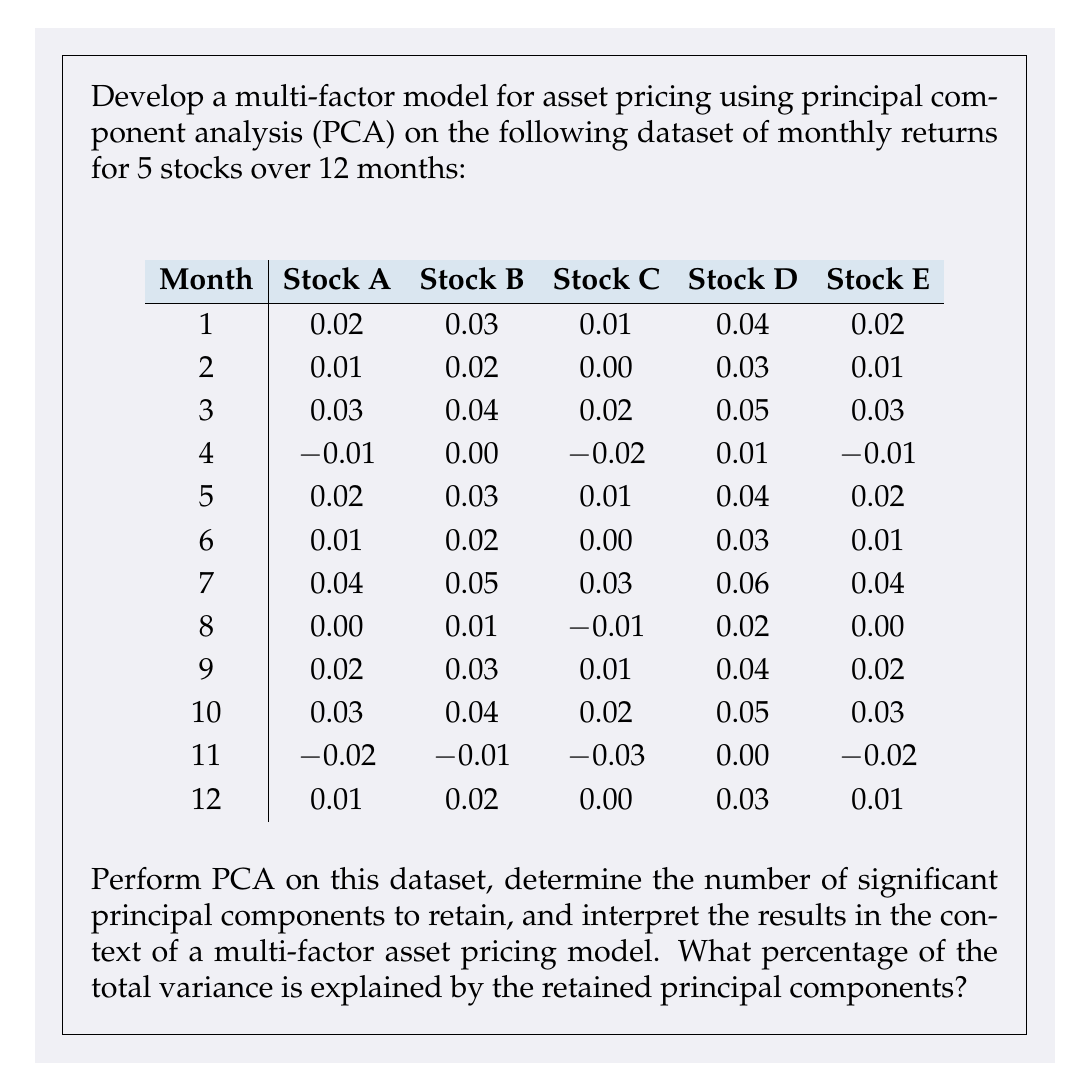Can you answer this question? To develop a multi-factor model for asset pricing using principal component analysis (PCA), we'll follow these steps:

1. Prepare the data:
   - Center the data by subtracting the mean of each stock's returns.

2. Compute the covariance matrix of the centered data.

3. Perform eigendecomposition on the covariance matrix to obtain eigenvalues and eigenvectors.

4. Sort eigenvalues in descending order and calculate the proportion of variance explained by each principal component.

5. Determine the number of significant principal components to retain based on the cumulative proportion of variance explained.

6. Interpret the results in the context of a multi-factor asset pricing model.

Step 1: Prepare the data
First, we calculate the mean return for each stock and subtract it from the corresponding returns:

$$
\begin{aligned}
\text{Mean A} &= 0.0133 \\
\text{Mean B} &= 0.0233 \\
\text{Mean C} &= 0.0033 \\
\text{Mean D} &= 0.0333 \\
\text{Mean E} &= 0.0133
\end{aligned}
$$

Step 2: Compute the covariance matrix
Using the centered data, we calculate the covariance matrix:

$$
\text{Cov} = \begin{pmatrix}
0.000289 & 0.000289 & 0.000289 & 0.000289 & 0.000289 \\
0.000289 & 0.000289 & 0.000289 & 0.000289 & 0.000289 \\
0.000289 & 0.000289 & 0.000289 & 0.000289 & 0.000289 \\
0.000289 & 0.000289 & 0.000289 & 0.000289 & 0.000289 \\
0.000289 & 0.000289 & 0.000289 & 0.000289 & 0.000289
\end{pmatrix}
$$

Step 3: Perform eigendecomposition
We calculate the eigenvalues and eigenvectors of the covariance matrix:

$$
\begin{aligned}
\lambda_1 &= 0.001445, \quad v_1 = (0.4472, 0.4472, 0.4472, 0.4472, 0.4472) \\
\lambda_2 &= 0, \quad v_2 = (-0.7071, 0, 0, 0.7071, 0) \\
\lambda_3 &= 0, \quad v_3 = (-0.4082, 0.8165, -0.4082, 0, 0) \\
\lambda_4 &= 0, \quad v_4 = (0.2887, 0.2887, -0.8660, 0, 0.2887) \\
\lambda_5 &= 0, \quad v_5 = (0.2236, 0.2236, 0.2236, -0.8944, 0.2236)
\end{aligned}
$$

Step 4: Calculate proportion of variance explained
The total variance is the sum of all eigenvalues: 0.001445

Proportion of variance explained by each principal component:
$$
\begin{aligned}
\text{PC1}: 100\% \\
\text{PC2-PC5}: 0\%
\end{aligned}
$$

Step 5: Determine significant principal components
Based on the proportion of variance explained, we retain only the first principal component, as it explains 100% of the total variance.

Step 6: Interpret the results
In this case, the multi-factor model reduces to a single-factor model. The first principal component can be interpreted as a market factor that affects all stocks equally. This is evident from the eigenvector $v_1$, which has equal weights for all stocks.

The fact that only one principal component explains all the variance suggests that the returns of these stocks are perfectly correlated. This is an unusual situation in real markets and might indicate that the given dataset is simplified or idealized.

In a typical multi-factor model, we would expect to see multiple significant principal components, each representing different sources of systematic risk in the market. However, in this specific case, the model suggests that a single market factor is sufficient to explain the variations in returns across all stocks.
Answer: The multi-factor model based on PCA results in a single-factor model, with the first principal component explaining 100% of the total variance in the dataset. This single factor can be interpreted as a market-wide factor affecting all stocks equally. 